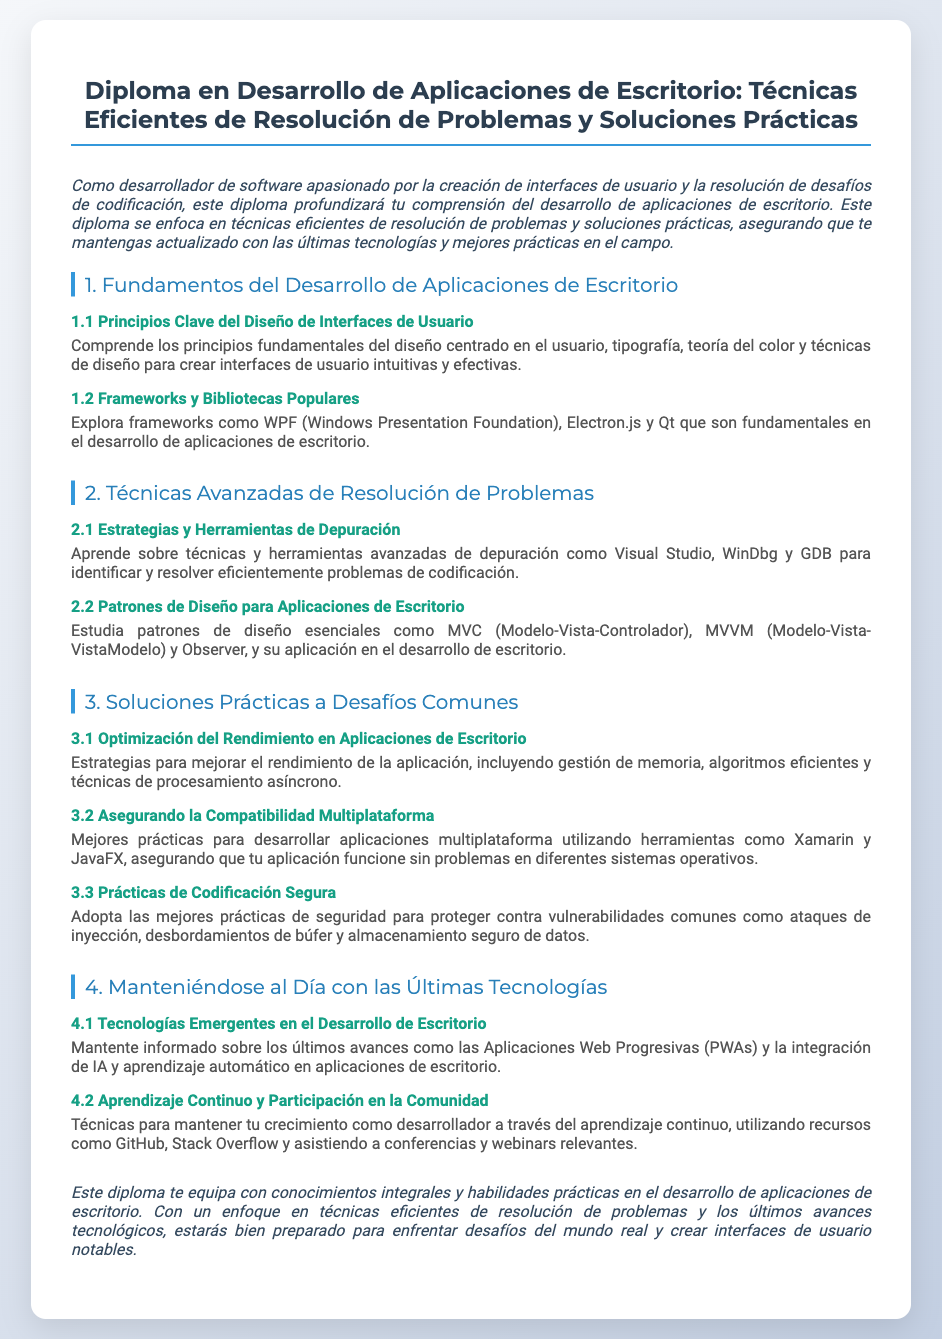¿Qué título tiene el diploma? El título del diploma es el encabezado de la sección principal y se puede ver en la parte superior del documento.
Answer: Diploma en Desarrollo de Aplicaciones de Escritorio: Técnicas Eficientes de Resolución de Problemas y Soluciones Prácticas ¿Cuántas secciones principales hay en el documento? Se pueden contar las secciones principales numeradas del documento en la parte del contenido.
Answer: 4 ¿Cuál es una de las herramientas de depuración mencionadas? Se puede identificar el nombre de una herramienta específica en la sección sobre técnicas de depuración.
Answer: Visual Studio ¿Qué patrón de diseño se estudia en el diploma? El texto menciona uno de los patrones de diseño como parte del contenido en la sección correspondiente.
Answer: MVC ¿Cuál es un enfoque para mejorar el rendimiento de la aplicación? En el documento se citan varias estrategias, una de las cuales se puede encontrar en la sección respecto al rendimiento.
Answer: Gestión de memoria ¿Qué tecnologías emergentes se mencionan? En la sección sobre tecnologías, se nombran ejemplos de tecnologías emergentes relevantes para el desarrollo de escritorio.
Answer: Aplicaciones Web Progresivas (PWAs) ¿Cuáles son dos recursos mencionados para el aprendizaje continuo? Se listan varios recursos en el documento que ayudan a los desarrolladores a crecer, se pueden encontrar en la sección de aprendizaje continuo.
Answer: GitHub, Stack Overflow ¿Cuál es el enfoque del diploma? Se describe el enfoque general del diploma en la introducción y se enfatiza la intención educativa.
Answer: Resolución de problemas y soluciones prácticas 